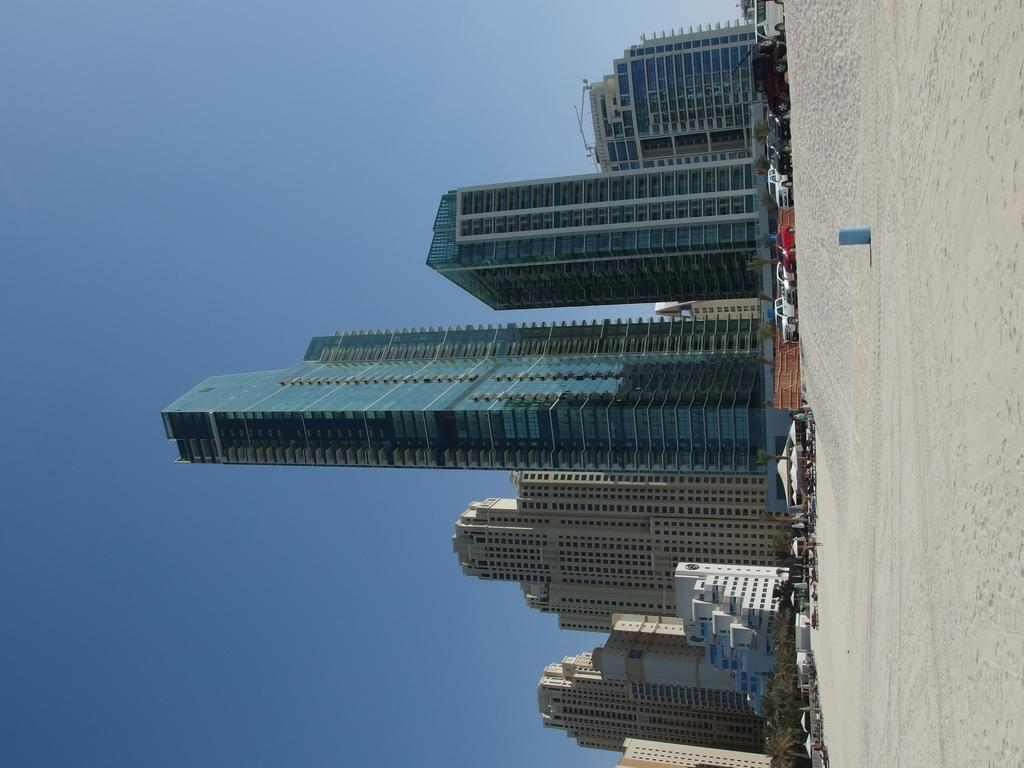What type of structures can be seen in the image? There are buildings in the image. What natural elements are present in the image? There are trees in the image. What temporary shelters can be seen in the image? There are tents in the image. What mode of transportation is visible in the image? There are vehicles in the image. What type of terrain is visible in the image? There is sand visible in the image. What part of the environment is visible in the image? The sky is visible in the image. What scientific discovery was made in the image? There is no scientific discovery mentioned or depicted in the image. How does the sand change color in the image? The sand does not change color in the image; it remains the same color throughout. 